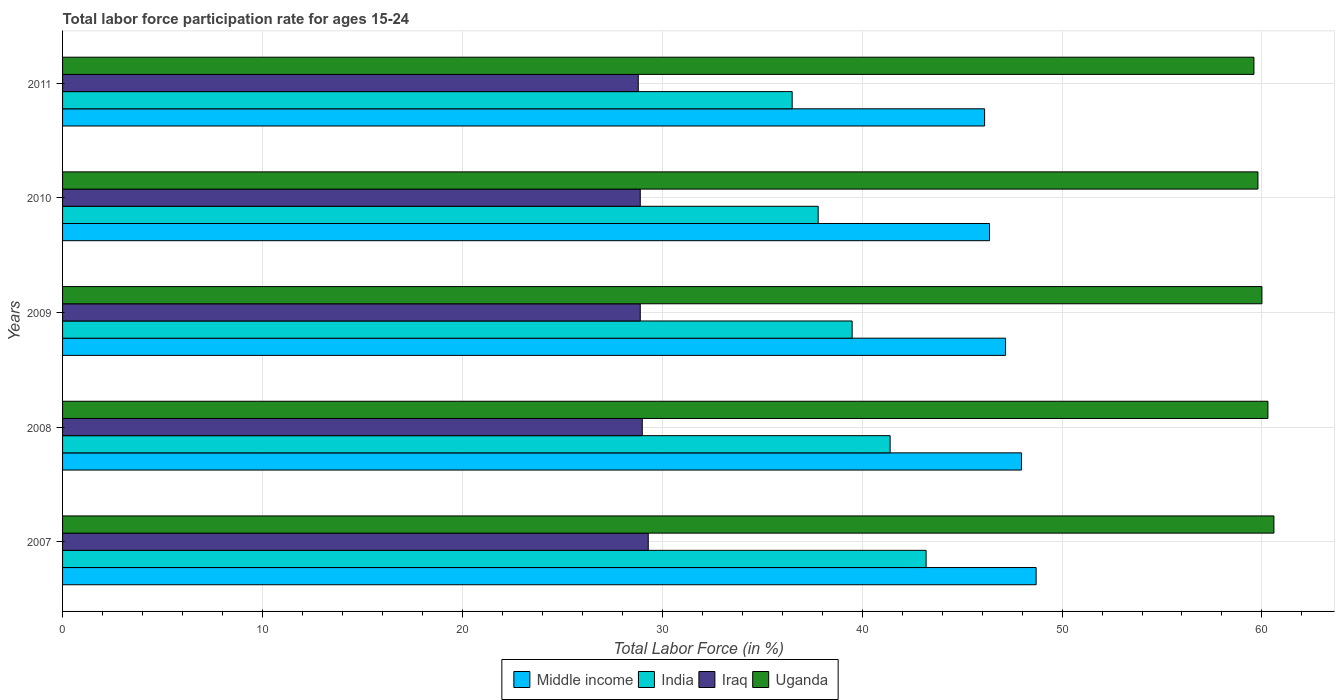How many different coloured bars are there?
Provide a succinct answer. 4. How many groups of bars are there?
Offer a terse response. 5. Are the number of bars per tick equal to the number of legend labels?
Keep it short and to the point. Yes. What is the label of the 4th group of bars from the top?
Make the answer very short. 2008. What is the labor force participation rate in Uganda in 2010?
Your response must be concise. 59.8. Across all years, what is the maximum labor force participation rate in Iraq?
Ensure brevity in your answer.  29.3. Across all years, what is the minimum labor force participation rate in India?
Your answer should be compact. 36.5. In which year was the labor force participation rate in India maximum?
Offer a very short reply. 2007. In which year was the labor force participation rate in Middle income minimum?
Your answer should be very brief. 2011. What is the total labor force participation rate in Uganda in the graph?
Provide a succinct answer. 300.3. What is the difference between the labor force participation rate in Iraq in 2010 and the labor force participation rate in Middle income in 2008?
Make the answer very short. -19.07. What is the average labor force participation rate in Uganda per year?
Give a very brief answer. 60.06. In the year 2007, what is the difference between the labor force participation rate in Middle income and labor force participation rate in Uganda?
Your answer should be very brief. -11.9. In how many years, is the labor force participation rate in Middle income greater than 8 %?
Your response must be concise. 5. What is the ratio of the labor force participation rate in Uganda in 2010 to that in 2011?
Your response must be concise. 1. What is the difference between the highest and the second highest labor force participation rate in Iraq?
Your response must be concise. 0.3. What is the difference between the highest and the lowest labor force participation rate in Iraq?
Your answer should be compact. 0.5. Is the sum of the labor force participation rate in Middle income in 2010 and 2011 greater than the maximum labor force participation rate in Uganda across all years?
Provide a short and direct response. Yes. Is it the case that in every year, the sum of the labor force participation rate in Middle income and labor force participation rate in India is greater than the sum of labor force participation rate in Iraq and labor force participation rate in Uganda?
Make the answer very short. No. What does the 2nd bar from the top in 2008 represents?
Offer a very short reply. Iraq. Is it the case that in every year, the sum of the labor force participation rate in India and labor force participation rate in Iraq is greater than the labor force participation rate in Middle income?
Your response must be concise. Yes. Are the values on the major ticks of X-axis written in scientific E-notation?
Keep it short and to the point. No. Where does the legend appear in the graph?
Your answer should be compact. Bottom center. How are the legend labels stacked?
Provide a short and direct response. Horizontal. What is the title of the graph?
Keep it short and to the point. Total labor force participation rate for ages 15-24. What is the Total Labor Force (in %) of Middle income in 2007?
Offer a terse response. 48.7. What is the Total Labor Force (in %) of India in 2007?
Keep it short and to the point. 43.2. What is the Total Labor Force (in %) in Iraq in 2007?
Your answer should be very brief. 29.3. What is the Total Labor Force (in %) in Uganda in 2007?
Offer a terse response. 60.6. What is the Total Labor Force (in %) of Middle income in 2008?
Offer a very short reply. 47.97. What is the Total Labor Force (in %) of India in 2008?
Ensure brevity in your answer.  41.4. What is the Total Labor Force (in %) of Uganda in 2008?
Keep it short and to the point. 60.3. What is the Total Labor Force (in %) of Middle income in 2009?
Your response must be concise. 47.17. What is the Total Labor Force (in %) of India in 2009?
Your answer should be compact. 39.5. What is the Total Labor Force (in %) of Iraq in 2009?
Ensure brevity in your answer.  28.9. What is the Total Labor Force (in %) in Uganda in 2009?
Your response must be concise. 60. What is the Total Labor Force (in %) of Middle income in 2010?
Keep it short and to the point. 46.37. What is the Total Labor Force (in %) of India in 2010?
Provide a succinct answer. 37.8. What is the Total Labor Force (in %) in Iraq in 2010?
Your answer should be very brief. 28.9. What is the Total Labor Force (in %) in Uganda in 2010?
Your response must be concise. 59.8. What is the Total Labor Force (in %) in Middle income in 2011?
Provide a short and direct response. 46.13. What is the Total Labor Force (in %) of India in 2011?
Your response must be concise. 36.5. What is the Total Labor Force (in %) of Iraq in 2011?
Offer a very short reply. 28.8. What is the Total Labor Force (in %) of Uganda in 2011?
Give a very brief answer. 59.6. Across all years, what is the maximum Total Labor Force (in %) in Middle income?
Offer a very short reply. 48.7. Across all years, what is the maximum Total Labor Force (in %) of India?
Your response must be concise. 43.2. Across all years, what is the maximum Total Labor Force (in %) in Iraq?
Provide a short and direct response. 29.3. Across all years, what is the maximum Total Labor Force (in %) in Uganda?
Give a very brief answer. 60.6. Across all years, what is the minimum Total Labor Force (in %) in Middle income?
Offer a very short reply. 46.13. Across all years, what is the minimum Total Labor Force (in %) in India?
Make the answer very short. 36.5. Across all years, what is the minimum Total Labor Force (in %) of Iraq?
Your answer should be very brief. 28.8. Across all years, what is the minimum Total Labor Force (in %) in Uganda?
Make the answer very short. 59.6. What is the total Total Labor Force (in %) in Middle income in the graph?
Give a very brief answer. 236.35. What is the total Total Labor Force (in %) of India in the graph?
Ensure brevity in your answer.  198.4. What is the total Total Labor Force (in %) in Iraq in the graph?
Ensure brevity in your answer.  144.9. What is the total Total Labor Force (in %) of Uganda in the graph?
Ensure brevity in your answer.  300.3. What is the difference between the Total Labor Force (in %) in Middle income in 2007 and that in 2008?
Make the answer very short. 0.73. What is the difference between the Total Labor Force (in %) of India in 2007 and that in 2008?
Keep it short and to the point. 1.8. What is the difference between the Total Labor Force (in %) of Middle income in 2007 and that in 2009?
Your response must be concise. 1.53. What is the difference between the Total Labor Force (in %) of Middle income in 2007 and that in 2010?
Your answer should be very brief. 2.33. What is the difference between the Total Labor Force (in %) of India in 2007 and that in 2010?
Make the answer very short. 5.4. What is the difference between the Total Labor Force (in %) of Iraq in 2007 and that in 2010?
Your answer should be compact. 0.4. What is the difference between the Total Labor Force (in %) in Middle income in 2007 and that in 2011?
Give a very brief answer. 2.58. What is the difference between the Total Labor Force (in %) of India in 2007 and that in 2011?
Ensure brevity in your answer.  6.7. What is the difference between the Total Labor Force (in %) in Iraq in 2007 and that in 2011?
Your answer should be very brief. 0.5. What is the difference between the Total Labor Force (in %) of Middle income in 2008 and that in 2009?
Provide a succinct answer. 0.8. What is the difference between the Total Labor Force (in %) of India in 2008 and that in 2009?
Your response must be concise. 1.9. What is the difference between the Total Labor Force (in %) of Iraq in 2008 and that in 2009?
Offer a very short reply. 0.1. What is the difference between the Total Labor Force (in %) of Middle income in 2008 and that in 2010?
Offer a terse response. 1.6. What is the difference between the Total Labor Force (in %) of Uganda in 2008 and that in 2010?
Offer a very short reply. 0.5. What is the difference between the Total Labor Force (in %) in Middle income in 2008 and that in 2011?
Keep it short and to the point. 1.85. What is the difference between the Total Labor Force (in %) in India in 2008 and that in 2011?
Provide a short and direct response. 4.9. What is the difference between the Total Labor Force (in %) of Iraq in 2008 and that in 2011?
Keep it short and to the point. 0.2. What is the difference between the Total Labor Force (in %) of Middle income in 2009 and that in 2010?
Your response must be concise. 0.8. What is the difference between the Total Labor Force (in %) in India in 2009 and that in 2010?
Provide a short and direct response. 1.7. What is the difference between the Total Labor Force (in %) in Uganda in 2009 and that in 2010?
Your response must be concise. 0.2. What is the difference between the Total Labor Force (in %) in Middle income in 2009 and that in 2011?
Your answer should be very brief. 1.05. What is the difference between the Total Labor Force (in %) of Uganda in 2009 and that in 2011?
Offer a terse response. 0.4. What is the difference between the Total Labor Force (in %) of Middle income in 2010 and that in 2011?
Offer a very short reply. 0.25. What is the difference between the Total Labor Force (in %) of India in 2010 and that in 2011?
Make the answer very short. 1.3. What is the difference between the Total Labor Force (in %) in Iraq in 2010 and that in 2011?
Your response must be concise. 0.1. What is the difference between the Total Labor Force (in %) of Uganda in 2010 and that in 2011?
Give a very brief answer. 0.2. What is the difference between the Total Labor Force (in %) of Middle income in 2007 and the Total Labor Force (in %) of India in 2008?
Your answer should be very brief. 7.3. What is the difference between the Total Labor Force (in %) of Middle income in 2007 and the Total Labor Force (in %) of Iraq in 2008?
Ensure brevity in your answer.  19.7. What is the difference between the Total Labor Force (in %) in Middle income in 2007 and the Total Labor Force (in %) in Uganda in 2008?
Ensure brevity in your answer.  -11.6. What is the difference between the Total Labor Force (in %) of India in 2007 and the Total Labor Force (in %) of Uganda in 2008?
Your answer should be very brief. -17.1. What is the difference between the Total Labor Force (in %) in Iraq in 2007 and the Total Labor Force (in %) in Uganda in 2008?
Provide a succinct answer. -31. What is the difference between the Total Labor Force (in %) of Middle income in 2007 and the Total Labor Force (in %) of India in 2009?
Offer a terse response. 9.2. What is the difference between the Total Labor Force (in %) in Middle income in 2007 and the Total Labor Force (in %) in Iraq in 2009?
Your answer should be compact. 19.8. What is the difference between the Total Labor Force (in %) in Middle income in 2007 and the Total Labor Force (in %) in Uganda in 2009?
Ensure brevity in your answer.  -11.3. What is the difference between the Total Labor Force (in %) of India in 2007 and the Total Labor Force (in %) of Iraq in 2009?
Keep it short and to the point. 14.3. What is the difference between the Total Labor Force (in %) in India in 2007 and the Total Labor Force (in %) in Uganda in 2009?
Offer a very short reply. -16.8. What is the difference between the Total Labor Force (in %) of Iraq in 2007 and the Total Labor Force (in %) of Uganda in 2009?
Provide a succinct answer. -30.7. What is the difference between the Total Labor Force (in %) in Middle income in 2007 and the Total Labor Force (in %) in India in 2010?
Your answer should be compact. 10.9. What is the difference between the Total Labor Force (in %) of Middle income in 2007 and the Total Labor Force (in %) of Iraq in 2010?
Make the answer very short. 19.8. What is the difference between the Total Labor Force (in %) in Middle income in 2007 and the Total Labor Force (in %) in Uganda in 2010?
Give a very brief answer. -11.1. What is the difference between the Total Labor Force (in %) in India in 2007 and the Total Labor Force (in %) in Uganda in 2010?
Your answer should be compact. -16.6. What is the difference between the Total Labor Force (in %) of Iraq in 2007 and the Total Labor Force (in %) of Uganda in 2010?
Your answer should be compact. -30.5. What is the difference between the Total Labor Force (in %) of Middle income in 2007 and the Total Labor Force (in %) of India in 2011?
Your answer should be very brief. 12.2. What is the difference between the Total Labor Force (in %) of Middle income in 2007 and the Total Labor Force (in %) of Iraq in 2011?
Provide a succinct answer. 19.9. What is the difference between the Total Labor Force (in %) in Middle income in 2007 and the Total Labor Force (in %) in Uganda in 2011?
Provide a succinct answer. -10.9. What is the difference between the Total Labor Force (in %) of India in 2007 and the Total Labor Force (in %) of Uganda in 2011?
Offer a very short reply. -16.4. What is the difference between the Total Labor Force (in %) in Iraq in 2007 and the Total Labor Force (in %) in Uganda in 2011?
Your answer should be very brief. -30.3. What is the difference between the Total Labor Force (in %) in Middle income in 2008 and the Total Labor Force (in %) in India in 2009?
Your answer should be compact. 8.47. What is the difference between the Total Labor Force (in %) in Middle income in 2008 and the Total Labor Force (in %) in Iraq in 2009?
Your answer should be very brief. 19.07. What is the difference between the Total Labor Force (in %) of Middle income in 2008 and the Total Labor Force (in %) of Uganda in 2009?
Your response must be concise. -12.03. What is the difference between the Total Labor Force (in %) in India in 2008 and the Total Labor Force (in %) in Iraq in 2009?
Provide a succinct answer. 12.5. What is the difference between the Total Labor Force (in %) in India in 2008 and the Total Labor Force (in %) in Uganda in 2009?
Make the answer very short. -18.6. What is the difference between the Total Labor Force (in %) of Iraq in 2008 and the Total Labor Force (in %) of Uganda in 2009?
Give a very brief answer. -31. What is the difference between the Total Labor Force (in %) of Middle income in 2008 and the Total Labor Force (in %) of India in 2010?
Give a very brief answer. 10.17. What is the difference between the Total Labor Force (in %) in Middle income in 2008 and the Total Labor Force (in %) in Iraq in 2010?
Ensure brevity in your answer.  19.07. What is the difference between the Total Labor Force (in %) in Middle income in 2008 and the Total Labor Force (in %) in Uganda in 2010?
Your response must be concise. -11.83. What is the difference between the Total Labor Force (in %) in India in 2008 and the Total Labor Force (in %) in Iraq in 2010?
Your answer should be very brief. 12.5. What is the difference between the Total Labor Force (in %) of India in 2008 and the Total Labor Force (in %) of Uganda in 2010?
Offer a very short reply. -18.4. What is the difference between the Total Labor Force (in %) in Iraq in 2008 and the Total Labor Force (in %) in Uganda in 2010?
Offer a very short reply. -30.8. What is the difference between the Total Labor Force (in %) of Middle income in 2008 and the Total Labor Force (in %) of India in 2011?
Offer a very short reply. 11.47. What is the difference between the Total Labor Force (in %) in Middle income in 2008 and the Total Labor Force (in %) in Iraq in 2011?
Offer a terse response. 19.17. What is the difference between the Total Labor Force (in %) of Middle income in 2008 and the Total Labor Force (in %) of Uganda in 2011?
Ensure brevity in your answer.  -11.63. What is the difference between the Total Labor Force (in %) of India in 2008 and the Total Labor Force (in %) of Iraq in 2011?
Give a very brief answer. 12.6. What is the difference between the Total Labor Force (in %) in India in 2008 and the Total Labor Force (in %) in Uganda in 2011?
Your response must be concise. -18.2. What is the difference between the Total Labor Force (in %) in Iraq in 2008 and the Total Labor Force (in %) in Uganda in 2011?
Keep it short and to the point. -30.6. What is the difference between the Total Labor Force (in %) of Middle income in 2009 and the Total Labor Force (in %) of India in 2010?
Provide a short and direct response. 9.37. What is the difference between the Total Labor Force (in %) of Middle income in 2009 and the Total Labor Force (in %) of Iraq in 2010?
Give a very brief answer. 18.27. What is the difference between the Total Labor Force (in %) in Middle income in 2009 and the Total Labor Force (in %) in Uganda in 2010?
Offer a terse response. -12.63. What is the difference between the Total Labor Force (in %) of India in 2009 and the Total Labor Force (in %) of Iraq in 2010?
Your answer should be compact. 10.6. What is the difference between the Total Labor Force (in %) of India in 2009 and the Total Labor Force (in %) of Uganda in 2010?
Your response must be concise. -20.3. What is the difference between the Total Labor Force (in %) of Iraq in 2009 and the Total Labor Force (in %) of Uganda in 2010?
Ensure brevity in your answer.  -30.9. What is the difference between the Total Labor Force (in %) in Middle income in 2009 and the Total Labor Force (in %) in India in 2011?
Your answer should be very brief. 10.67. What is the difference between the Total Labor Force (in %) in Middle income in 2009 and the Total Labor Force (in %) in Iraq in 2011?
Ensure brevity in your answer.  18.37. What is the difference between the Total Labor Force (in %) of Middle income in 2009 and the Total Labor Force (in %) of Uganda in 2011?
Keep it short and to the point. -12.43. What is the difference between the Total Labor Force (in %) of India in 2009 and the Total Labor Force (in %) of Iraq in 2011?
Offer a very short reply. 10.7. What is the difference between the Total Labor Force (in %) in India in 2009 and the Total Labor Force (in %) in Uganda in 2011?
Ensure brevity in your answer.  -20.1. What is the difference between the Total Labor Force (in %) in Iraq in 2009 and the Total Labor Force (in %) in Uganda in 2011?
Ensure brevity in your answer.  -30.7. What is the difference between the Total Labor Force (in %) of Middle income in 2010 and the Total Labor Force (in %) of India in 2011?
Your answer should be very brief. 9.87. What is the difference between the Total Labor Force (in %) of Middle income in 2010 and the Total Labor Force (in %) of Iraq in 2011?
Give a very brief answer. 17.57. What is the difference between the Total Labor Force (in %) of Middle income in 2010 and the Total Labor Force (in %) of Uganda in 2011?
Make the answer very short. -13.23. What is the difference between the Total Labor Force (in %) of India in 2010 and the Total Labor Force (in %) of Iraq in 2011?
Keep it short and to the point. 9. What is the difference between the Total Labor Force (in %) in India in 2010 and the Total Labor Force (in %) in Uganda in 2011?
Provide a succinct answer. -21.8. What is the difference between the Total Labor Force (in %) in Iraq in 2010 and the Total Labor Force (in %) in Uganda in 2011?
Provide a succinct answer. -30.7. What is the average Total Labor Force (in %) of Middle income per year?
Ensure brevity in your answer.  47.27. What is the average Total Labor Force (in %) of India per year?
Your answer should be very brief. 39.68. What is the average Total Labor Force (in %) in Iraq per year?
Offer a terse response. 28.98. What is the average Total Labor Force (in %) in Uganda per year?
Provide a short and direct response. 60.06. In the year 2007, what is the difference between the Total Labor Force (in %) of Middle income and Total Labor Force (in %) of India?
Ensure brevity in your answer.  5.5. In the year 2007, what is the difference between the Total Labor Force (in %) of Middle income and Total Labor Force (in %) of Iraq?
Ensure brevity in your answer.  19.4. In the year 2007, what is the difference between the Total Labor Force (in %) of Middle income and Total Labor Force (in %) of Uganda?
Offer a very short reply. -11.9. In the year 2007, what is the difference between the Total Labor Force (in %) of India and Total Labor Force (in %) of Iraq?
Keep it short and to the point. 13.9. In the year 2007, what is the difference between the Total Labor Force (in %) of India and Total Labor Force (in %) of Uganda?
Your answer should be compact. -17.4. In the year 2007, what is the difference between the Total Labor Force (in %) of Iraq and Total Labor Force (in %) of Uganda?
Offer a terse response. -31.3. In the year 2008, what is the difference between the Total Labor Force (in %) in Middle income and Total Labor Force (in %) in India?
Keep it short and to the point. 6.57. In the year 2008, what is the difference between the Total Labor Force (in %) of Middle income and Total Labor Force (in %) of Iraq?
Keep it short and to the point. 18.97. In the year 2008, what is the difference between the Total Labor Force (in %) of Middle income and Total Labor Force (in %) of Uganda?
Make the answer very short. -12.33. In the year 2008, what is the difference between the Total Labor Force (in %) in India and Total Labor Force (in %) in Iraq?
Your response must be concise. 12.4. In the year 2008, what is the difference between the Total Labor Force (in %) in India and Total Labor Force (in %) in Uganda?
Your answer should be very brief. -18.9. In the year 2008, what is the difference between the Total Labor Force (in %) of Iraq and Total Labor Force (in %) of Uganda?
Ensure brevity in your answer.  -31.3. In the year 2009, what is the difference between the Total Labor Force (in %) of Middle income and Total Labor Force (in %) of India?
Keep it short and to the point. 7.67. In the year 2009, what is the difference between the Total Labor Force (in %) of Middle income and Total Labor Force (in %) of Iraq?
Ensure brevity in your answer.  18.27. In the year 2009, what is the difference between the Total Labor Force (in %) in Middle income and Total Labor Force (in %) in Uganda?
Offer a terse response. -12.83. In the year 2009, what is the difference between the Total Labor Force (in %) of India and Total Labor Force (in %) of Uganda?
Your response must be concise. -20.5. In the year 2009, what is the difference between the Total Labor Force (in %) in Iraq and Total Labor Force (in %) in Uganda?
Offer a very short reply. -31.1. In the year 2010, what is the difference between the Total Labor Force (in %) in Middle income and Total Labor Force (in %) in India?
Provide a short and direct response. 8.57. In the year 2010, what is the difference between the Total Labor Force (in %) in Middle income and Total Labor Force (in %) in Iraq?
Keep it short and to the point. 17.47. In the year 2010, what is the difference between the Total Labor Force (in %) in Middle income and Total Labor Force (in %) in Uganda?
Provide a succinct answer. -13.43. In the year 2010, what is the difference between the Total Labor Force (in %) in India and Total Labor Force (in %) in Iraq?
Ensure brevity in your answer.  8.9. In the year 2010, what is the difference between the Total Labor Force (in %) in Iraq and Total Labor Force (in %) in Uganda?
Give a very brief answer. -30.9. In the year 2011, what is the difference between the Total Labor Force (in %) of Middle income and Total Labor Force (in %) of India?
Your answer should be compact. 9.63. In the year 2011, what is the difference between the Total Labor Force (in %) of Middle income and Total Labor Force (in %) of Iraq?
Ensure brevity in your answer.  17.33. In the year 2011, what is the difference between the Total Labor Force (in %) of Middle income and Total Labor Force (in %) of Uganda?
Your answer should be compact. -13.47. In the year 2011, what is the difference between the Total Labor Force (in %) of India and Total Labor Force (in %) of Uganda?
Make the answer very short. -23.1. In the year 2011, what is the difference between the Total Labor Force (in %) in Iraq and Total Labor Force (in %) in Uganda?
Provide a short and direct response. -30.8. What is the ratio of the Total Labor Force (in %) in Middle income in 2007 to that in 2008?
Your answer should be compact. 1.02. What is the ratio of the Total Labor Force (in %) in India in 2007 to that in 2008?
Your response must be concise. 1.04. What is the ratio of the Total Labor Force (in %) of Iraq in 2007 to that in 2008?
Your answer should be compact. 1.01. What is the ratio of the Total Labor Force (in %) in Uganda in 2007 to that in 2008?
Offer a terse response. 1. What is the ratio of the Total Labor Force (in %) of Middle income in 2007 to that in 2009?
Keep it short and to the point. 1.03. What is the ratio of the Total Labor Force (in %) of India in 2007 to that in 2009?
Ensure brevity in your answer.  1.09. What is the ratio of the Total Labor Force (in %) in Iraq in 2007 to that in 2009?
Make the answer very short. 1.01. What is the ratio of the Total Labor Force (in %) in Uganda in 2007 to that in 2009?
Give a very brief answer. 1.01. What is the ratio of the Total Labor Force (in %) in Middle income in 2007 to that in 2010?
Your answer should be compact. 1.05. What is the ratio of the Total Labor Force (in %) in India in 2007 to that in 2010?
Provide a succinct answer. 1.14. What is the ratio of the Total Labor Force (in %) of Iraq in 2007 to that in 2010?
Provide a succinct answer. 1.01. What is the ratio of the Total Labor Force (in %) in Uganda in 2007 to that in 2010?
Make the answer very short. 1.01. What is the ratio of the Total Labor Force (in %) in Middle income in 2007 to that in 2011?
Offer a very short reply. 1.06. What is the ratio of the Total Labor Force (in %) of India in 2007 to that in 2011?
Give a very brief answer. 1.18. What is the ratio of the Total Labor Force (in %) of Iraq in 2007 to that in 2011?
Your response must be concise. 1.02. What is the ratio of the Total Labor Force (in %) of Uganda in 2007 to that in 2011?
Make the answer very short. 1.02. What is the ratio of the Total Labor Force (in %) of Middle income in 2008 to that in 2009?
Your answer should be very brief. 1.02. What is the ratio of the Total Labor Force (in %) in India in 2008 to that in 2009?
Your answer should be very brief. 1.05. What is the ratio of the Total Labor Force (in %) of Iraq in 2008 to that in 2009?
Offer a terse response. 1. What is the ratio of the Total Labor Force (in %) of Middle income in 2008 to that in 2010?
Ensure brevity in your answer.  1.03. What is the ratio of the Total Labor Force (in %) of India in 2008 to that in 2010?
Ensure brevity in your answer.  1.1. What is the ratio of the Total Labor Force (in %) in Iraq in 2008 to that in 2010?
Make the answer very short. 1. What is the ratio of the Total Labor Force (in %) of Uganda in 2008 to that in 2010?
Your answer should be compact. 1.01. What is the ratio of the Total Labor Force (in %) of India in 2008 to that in 2011?
Provide a succinct answer. 1.13. What is the ratio of the Total Labor Force (in %) in Iraq in 2008 to that in 2011?
Keep it short and to the point. 1.01. What is the ratio of the Total Labor Force (in %) in Uganda in 2008 to that in 2011?
Give a very brief answer. 1.01. What is the ratio of the Total Labor Force (in %) in Middle income in 2009 to that in 2010?
Provide a short and direct response. 1.02. What is the ratio of the Total Labor Force (in %) of India in 2009 to that in 2010?
Your answer should be very brief. 1.04. What is the ratio of the Total Labor Force (in %) in Iraq in 2009 to that in 2010?
Provide a short and direct response. 1. What is the ratio of the Total Labor Force (in %) of Middle income in 2009 to that in 2011?
Your answer should be compact. 1.02. What is the ratio of the Total Labor Force (in %) of India in 2009 to that in 2011?
Your answer should be compact. 1.08. What is the ratio of the Total Labor Force (in %) of Uganda in 2009 to that in 2011?
Make the answer very short. 1.01. What is the ratio of the Total Labor Force (in %) in India in 2010 to that in 2011?
Your answer should be very brief. 1.04. What is the difference between the highest and the second highest Total Labor Force (in %) in Middle income?
Ensure brevity in your answer.  0.73. What is the difference between the highest and the second highest Total Labor Force (in %) in Iraq?
Give a very brief answer. 0.3. What is the difference between the highest and the second highest Total Labor Force (in %) of Uganda?
Make the answer very short. 0.3. What is the difference between the highest and the lowest Total Labor Force (in %) in Middle income?
Your answer should be compact. 2.58. What is the difference between the highest and the lowest Total Labor Force (in %) in India?
Make the answer very short. 6.7. What is the difference between the highest and the lowest Total Labor Force (in %) of Iraq?
Your response must be concise. 0.5. 